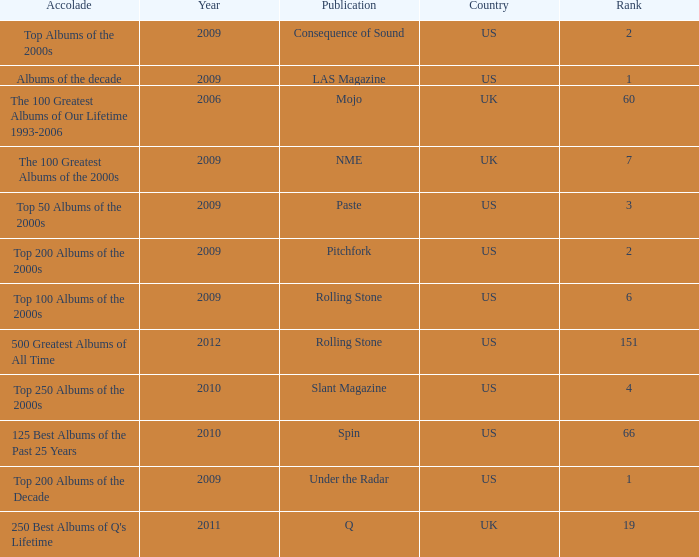What was the lowest rank after 2009 with an accolade of 125 best albums of the past 25 years? 66.0. 